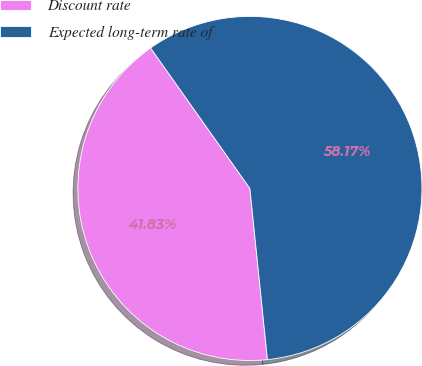Convert chart to OTSL. <chart><loc_0><loc_0><loc_500><loc_500><pie_chart><fcel>Discount rate<fcel>Expected long-term rate of<nl><fcel>41.83%<fcel>58.17%<nl></chart> 